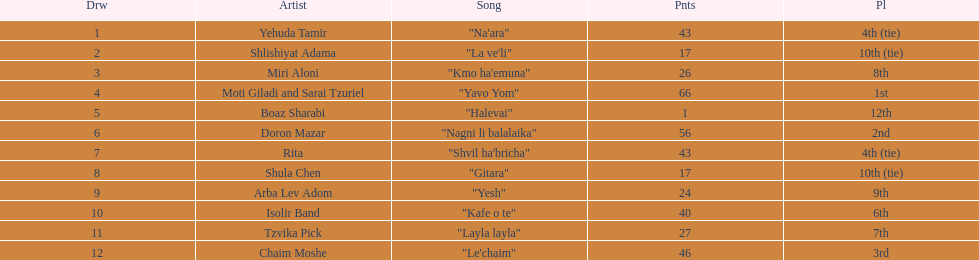What is the name of the song listed before the song "yesh"? "Gitara". 